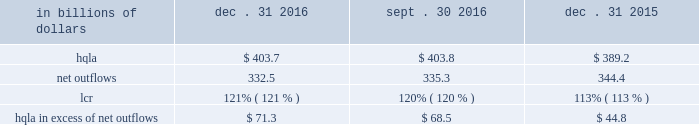Liquidity monitoring and measurement stress testing liquidity stress testing is performed for each of citi 2019s major entities , operating subsidiaries and/or countries .
Stress testing and scenario analyses are intended to quantify the potential impact of a liquidity event on the balance sheet and liquidity position , and to identify viable funding alternatives that can be utilized .
These scenarios include assumptions about significant changes in key funding sources , market triggers ( such as credit ratings ) , potential uses of funding and political and economic conditions in certain countries .
These conditions include expected and stressed market conditions as well as company- specific events .
Liquidity stress tests are conducted to ascertain potential mismatches between liquidity sources and uses over a variety of time horizons ( overnight , one week , two weeks , one month , three months , one year ) and over a variety of stressed conditions .
Liquidity limits are set accordingly .
To monitor the liquidity of an entity , these stress tests and potential mismatches are calculated with varying frequencies , with several tests performed daily .
Given the range of potential stresses , citi maintains a series of contingency funding plans on a consolidated basis and for individual entities .
These plans specify a wide range of readily available actions for a variety of adverse market conditions or idiosyncratic stresses .
Short-term liquidity measurement : liquidity coverage ratio ( lcr ) in addition to internal measures that citi has developed for a 30-day stress scenario , citi also monitors its liquidity by reference to the lcr , as calculated pursuant to the u.s .
Lcr rules .
Generally , the lcr is designed to ensure that banks maintain an adequate level of hqla to meet liquidity needs under an acute 30-day stress scenario .
The lcr is calculated by dividing hqla by estimated net outflows over a stressed 30-day period , with the net outflows determined by applying prescribed outflow factors to various categories of liabilities , such as deposits , unsecured and secured wholesale borrowings , unused lending commitments and derivatives- related exposures , partially offset by inflows from assets maturing within 30 days .
Banks are required to calculate an add-on to address potential maturity mismatches between contractual cash outflows and inflows within the 30-day period in determining the total amount of net outflows .
The minimum lcr requirement is 100% ( 100 % ) , effective january 2017 .
In december 2016 , the federal reserve board adopted final rules which require additional disclosures relating to the lcr of large financial institutions , including citi .
Among other things , the final rules require citi to disclose components of its average hqla , lcr and inflows and outflows each quarter .
In addition , the final rules require disclosure of citi 2019s calculation of the maturity mismatch add-on as well as other qualitative disclosures .
The effective date for these disclosures is april 1 , 2017 .
The table below sets forth the components of citi 2019s lcr calculation and hqla in excess of net outflows for the periods indicated : in billions of dollars dec .
31 , sept .
30 , dec .
31 .
Note : amounts set forth in the table above are presented on an average basis .
As set forth in the table above , citi 2019s lcr increased both year-over-year and sequentially .
The increase year-over-year was driven by both an increase in hqla and a reduction in net outflows .
Sequentially , the increase was driven by a slight reduction in net outflows , as hqla remained largely unchanged .
Long-term liquidity measurement : net stable funding ratio ( nsfr ) in the second quarter of 2016 , the federal reserve board , the fdic and the occ issued a proposed rule to implement the basel iii nsfr requirement .
The u.s.-proposed nsfr is largely consistent with the basel committee 2019s final nsfr rules .
In general , the nsfr assesses the availability of a bank 2019s stable funding against a required level .
A bank 2019s available stable funding would include portions of equity , deposits and long-term debt , while its required stable funding would be based on the liquidity characteristics of its assets , derivatives and commitments .
Standardized weightings would be required to be applied to the various asset and liabilities classes .
The ratio of available stable funding to required stable funding would be required to be greater than 100% ( 100 % ) .
While citi believes that it is compliant with the proposed u.s .
Nsfr rules as of december 31 , 2016 , it will need to evaluate any final version of the rules , which are expected to be released during 2017 .
The proposed rules would require full implementation of the u.s .
Nsfr beginning january 1 , 2018. .
What was the change in billions of hqa from december 31 , 2015 to december 31 , 2016? 
Computations: (403.7 - 389.2)
Answer: 14.5. 